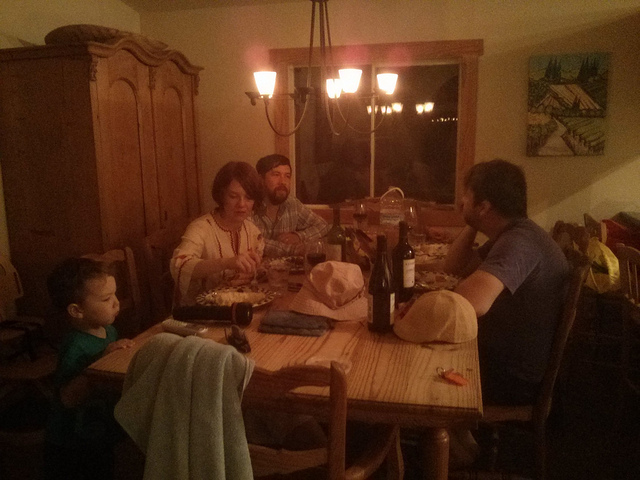<image>What is on top of the China cabinet? I don't know what is on top of the China cabinet. It can be dishes, a basket, a pillow, an object, a blanket or a tablecloth. What is on top of the China cabinet? I don't know what is on top of the China cabinet. It can be nothing, dishes, basket, pillow, object, or blanket/tablecloth. 